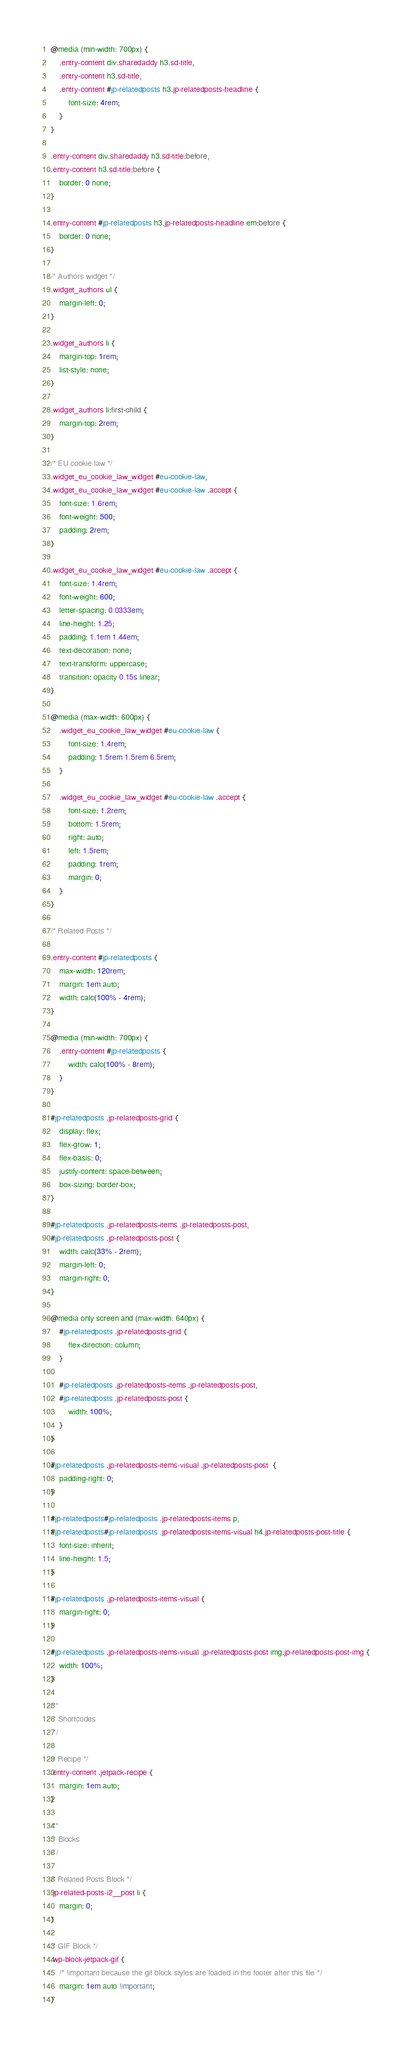<code> <loc_0><loc_0><loc_500><loc_500><_CSS_>@media (min-width: 700px) {
	.entry-content div.sharedaddy h3.sd-title,
	.entry-content h3.sd-title,
	.entry-content #jp-relatedposts h3.jp-relatedposts-headline {
		font-size: 4rem;
	}
}

.entry-content div.sharedaddy h3.sd-title:before,
.entry-content h3.sd-title:before {
	border: 0 none;
}

.entry-content #jp-relatedposts h3.jp-relatedposts-headline em:before {
	border: 0 none;
}

/* Authors widget */
.widget_authors ul {
	margin-left: 0;
}

.widget_authors li {
	margin-top: 1rem;
	list-style: none;
}

.widget_authors li:first-child {
	margin-top: 2rem;
}

/* EU cookie law */
.widget_eu_cookie_law_widget #eu-cookie-law,
.widget_eu_cookie_law_widget #eu-cookie-law .accept {
	font-size: 1.6rem;
	font-weight: 500;
	padding: 2rem;
}

.widget_eu_cookie_law_widget #eu-cookie-law .accept {
	font-size: 1.4rem;
	font-weight: 600;
	letter-spacing: 0.0333em;
	line-height: 1.25;
	padding: 1.1em 1.44em;
	text-decoration: none;
	text-transform: uppercase;
	transition: opacity 0.15s linear;
}

@media (max-width: 600px) {
	.widget_eu_cookie_law_widget #eu-cookie-law {
		font-size: 1.4rem;
		padding: 1.5rem 1.5rem 6.5rem;
	}

	.widget_eu_cookie_law_widget #eu-cookie-law .accept {
		font-size: 1.2rem;
		bottom: 1.5rem;
		right: auto;
		left: 1.5rem;
		padding: 1rem;
		margin: 0;
	}
}

/* Related Posts */

.entry-content #jp-relatedposts {
	max-width: 120rem;
	margin: 1em auto;
	width: calc(100% - 4rem);
}

@media (min-width: 700px) {
	.entry-content #jp-relatedposts {
		width: calc(100% - 8rem);
	}
}

#jp-relatedposts .jp-relatedposts-grid {
	display: flex;
	flex-grow: 1;
	flex-basis: 0;
	justify-content: space-between;
	box-sizing: border-box;
}

#jp-relatedposts .jp-relatedposts-items .jp-relatedposts-post,
#jp-relatedposts .jp-relatedposts-post {
	width: calc(33% - 2rem);
	margin-left: 0;
	margin-right: 0;
}

@media only screen and (max-width: 640px) {
	#jp-relatedposts .jp-relatedposts-grid {
		flex-direction: column;
	}

	#jp-relatedposts .jp-relatedposts-items .jp-relatedposts-post,
	#jp-relatedposts .jp-relatedposts-post {
		width: 100%;
	}
}

#jp-relatedposts .jp-relatedposts-items-visual .jp-relatedposts-post  {
	padding-right: 0;
}

#jp-relatedposts#jp-relatedposts .jp-relatedposts-items p,
#jp-relatedposts#jp-relatedposts .jp-relatedposts-items-visual h4.jp-relatedposts-post-title {
	font-size: inherit;
	line-height: 1.5;
}

#jp-relatedposts .jp-relatedposts-items-visual {
	margin-right: 0;
}

#jp-relatedposts .jp-relatedposts-items-visual .jp-relatedposts-post img.jp-relatedposts-post-img {
	width: 100%;
}

/**
 * Shortcodes
 */

/* Recipe */
.entry-content .jetpack-recipe {
	margin: 1em auto;
}

/**
 * Blocks
 */

/* Related Posts Block */
.jp-related-posts-i2__post li {
	margin: 0;
}

/* GIF Block */
.wp-block-jetpack-gif {
	/* !important because the gif block styles are loaded in the footer after this file */
	margin: 1em auto !important;
}
</code> 